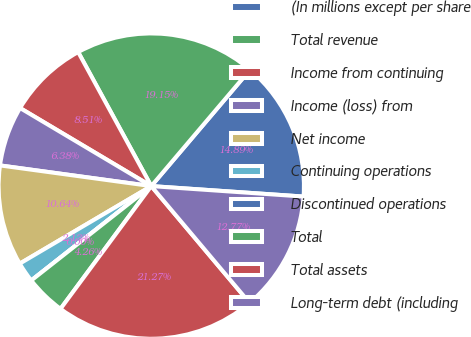Convert chart. <chart><loc_0><loc_0><loc_500><loc_500><pie_chart><fcel>(In millions except per share<fcel>Total revenue<fcel>Income from continuing<fcel>Income (loss) from<fcel>Net income<fcel>Continuing operations<fcel>Discontinued operations<fcel>Total<fcel>Total assets<fcel>Long-term debt (including<nl><fcel>14.89%<fcel>19.15%<fcel>8.51%<fcel>6.38%<fcel>10.64%<fcel>2.13%<fcel>0.0%<fcel>4.26%<fcel>21.27%<fcel>12.77%<nl></chart> 